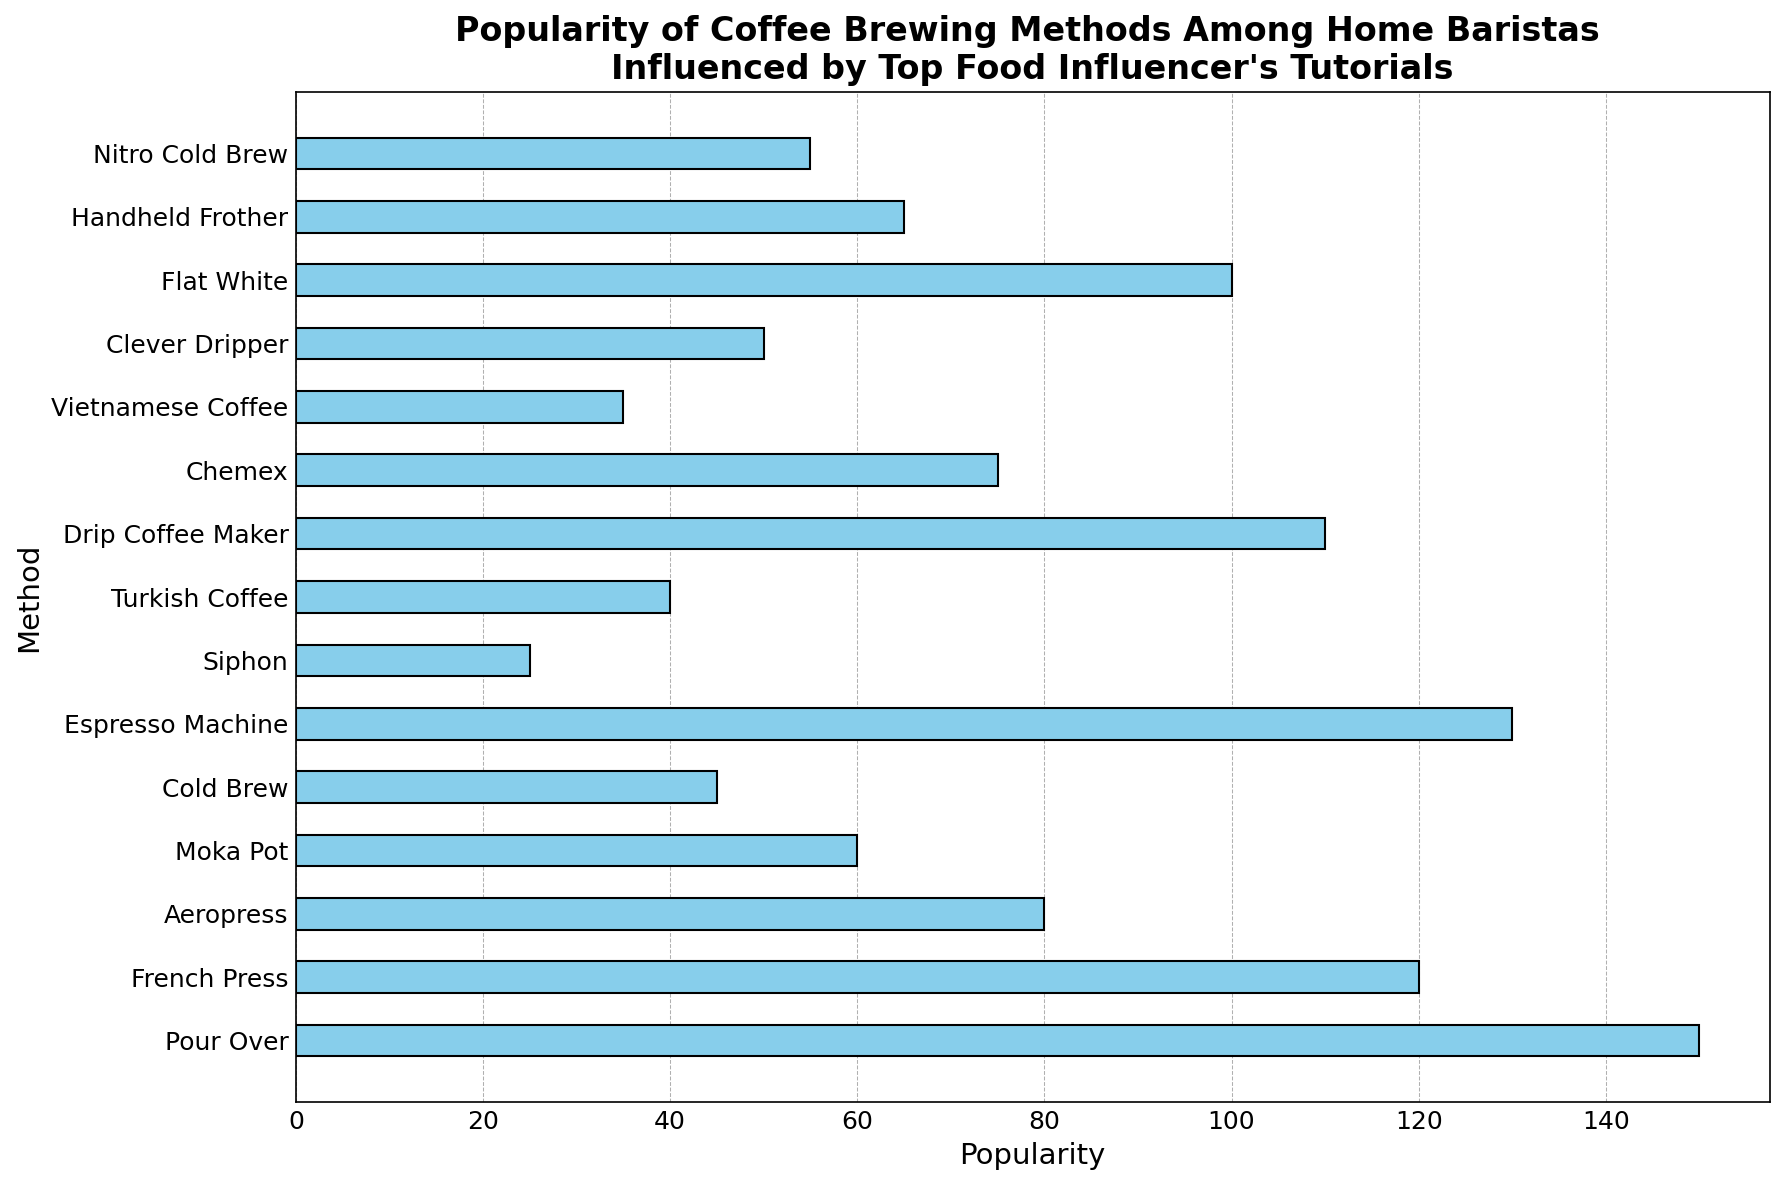What is the most popular coffee brewing method among home baristas according to the figure? The tallest or longest bar in the histogram represents the most popular method. By looking at the figure, the 'Pour Over' method has the highest bar.
Answer: Pour Over What is the least popular coffee brewing method among home baristas as shown in the figure? The shortest or smallest bar in the histogram represents the least popular method. By looking at the figure, the 'Siphon' method has the shortest bar.
Answer: Siphon How much more popular is the 'Espresso Machine' method compared to the 'Aeropress' method? Locate the bars for 'Espresso Machine' and 'Aeropress' in the histogram; measure their heights. The 'Espresso Machine' is at 130 and 'Aeropress' at 80. Subtract the popularity of Aeropress from Espresso Machine (130 - 80 = 50).
Answer: 50 What is the combined popularity of 'Cold Brew' and 'Nitro Cold Brew'? Add the popularity values of 'Cold Brew' and 'Nitro Cold Brew'. Cold Brew is at 45, and Nitro Cold Brew is at 55. Therefore, 45 + 55 = 100.
Answer: 100 Is 'French Press' more or less popular than 'Drip Coffee Maker'? Compare the heights of the bars for 'French Press' and 'Drip Coffee Maker'. 'French Press' has a popularity value of 120, while 'Drip Coffee Maker' has 110. So, 'French Press' is more popular.
Answer: More popular Which method has a popularity value equal to 50? Locate the bar that has a height/value of 50 in the histogram. The bar corresponding to 'Clever Dripper' has a value of 50.
Answer: Clever Dripper What is the difference in popularity between 'Moka Pot' and 'Vietnamese Coffee'? Identify the popularity values for 'Moka Pot' and 'Vietnamese Coffee'. 'Moka Pot' is 60 and 'Vietnamese Coffee' is 35. Subtract Vietnamese Coffee's value from Moka Pot's value (60 - 35 = 25).
Answer: 25 Which brewing methods have popularity values greater than 100? Find all the bars in the histogram with heights above 100. 'Pour Over' (150), 'Espresso Machine' (130), 'French Press' (120), and 'Drip Coffee Maker' (110) have values greater than 100.
Answer: Pour Over, Espresso Machine, French Press, Drip Coffee Maker What is the average popularity value of the top three most popular brewing methods? Identify and sum the popularity values of the top three methods: 'Pour Over' (150), 'Espresso Machine' (130), and 'French Press' (120). Calculate the average: (150 + 130 + 120) / 3 = 133.33.
Answer: 133.33 What proportion of the popularity does the 'Chemex' method have relative to the 'Flat White' method? Calculate the proportion by dividing the popularity of 'Chemex' by that of 'Flat White'. 'Chemex' is 75 and 'Flat White' is 100. Thus, 75 / 100 = 0.75.
Answer: 0.75 